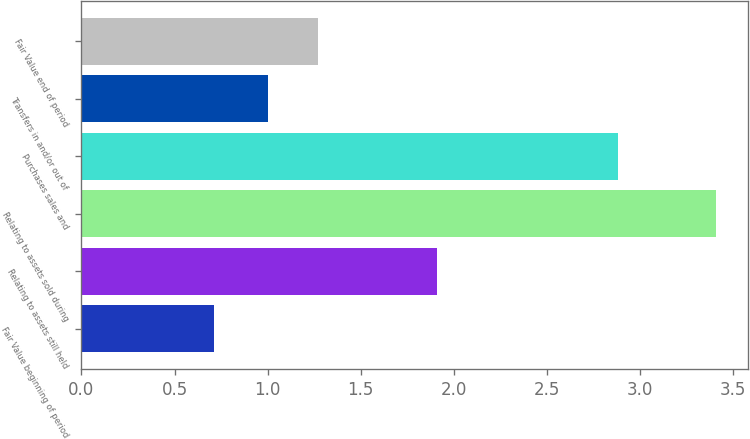<chart> <loc_0><loc_0><loc_500><loc_500><bar_chart><fcel>Fair Value beginning of period<fcel>Relating to assets still held<fcel>Relating to assets sold during<fcel>Purchases sales and<fcel>Transfers in and/or out of<fcel>Fair Value end of period<nl><fcel>0.71<fcel>1.91<fcel>3.41<fcel>2.88<fcel>1<fcel>1.27<nl></chart> 